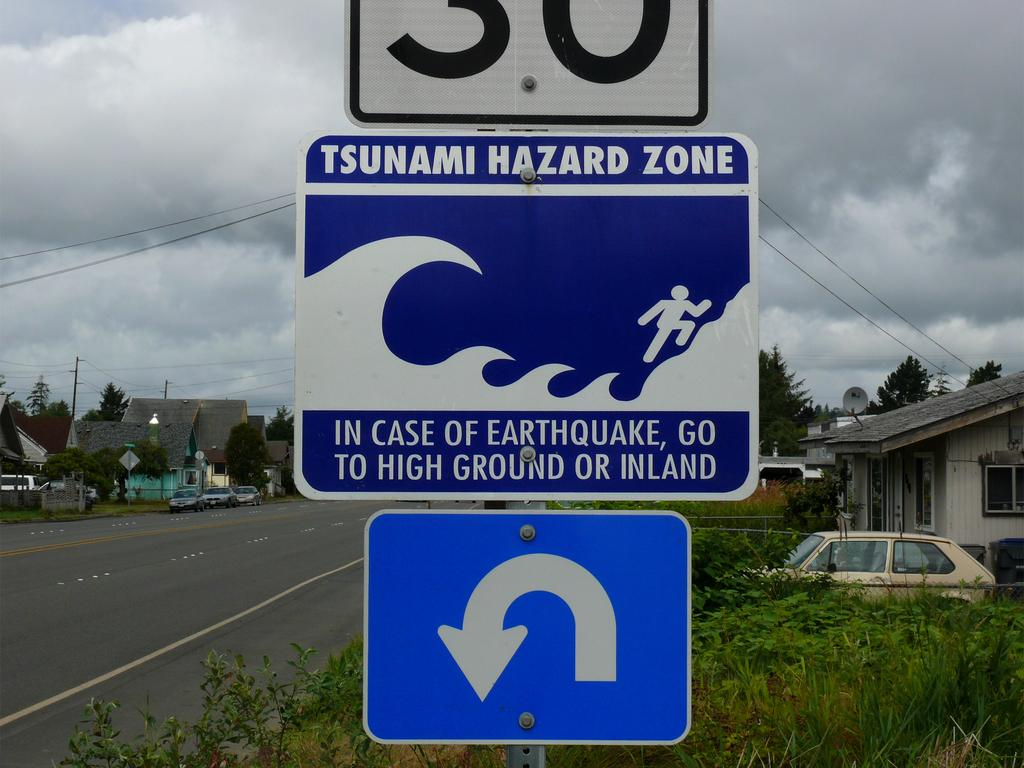<image>
Provide a brief description of the given image. A sign on the side of the street warns of a tsunami hazard zone. 